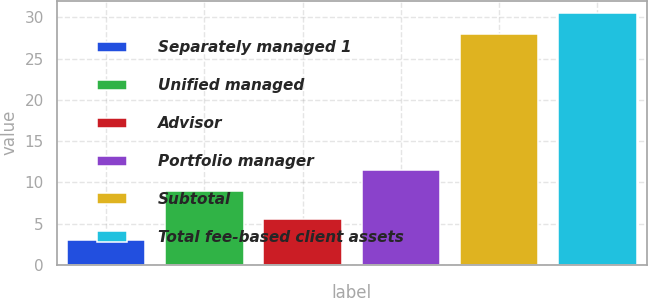Convert chart. <chart><loc_0><loc_0><loc_500><loc_500><bar_chart><fcel>Separately managed 1<fcel>Unified managed<fcel>Advisor<fcel>Portfolio manager<fcel>Subtotal<fcel>Total fee-based client assets<nl><fcel>3<fcel>9<fcel>5.5<fcel>11.5<fcel>28<fcel>30.5<nl></chart> 